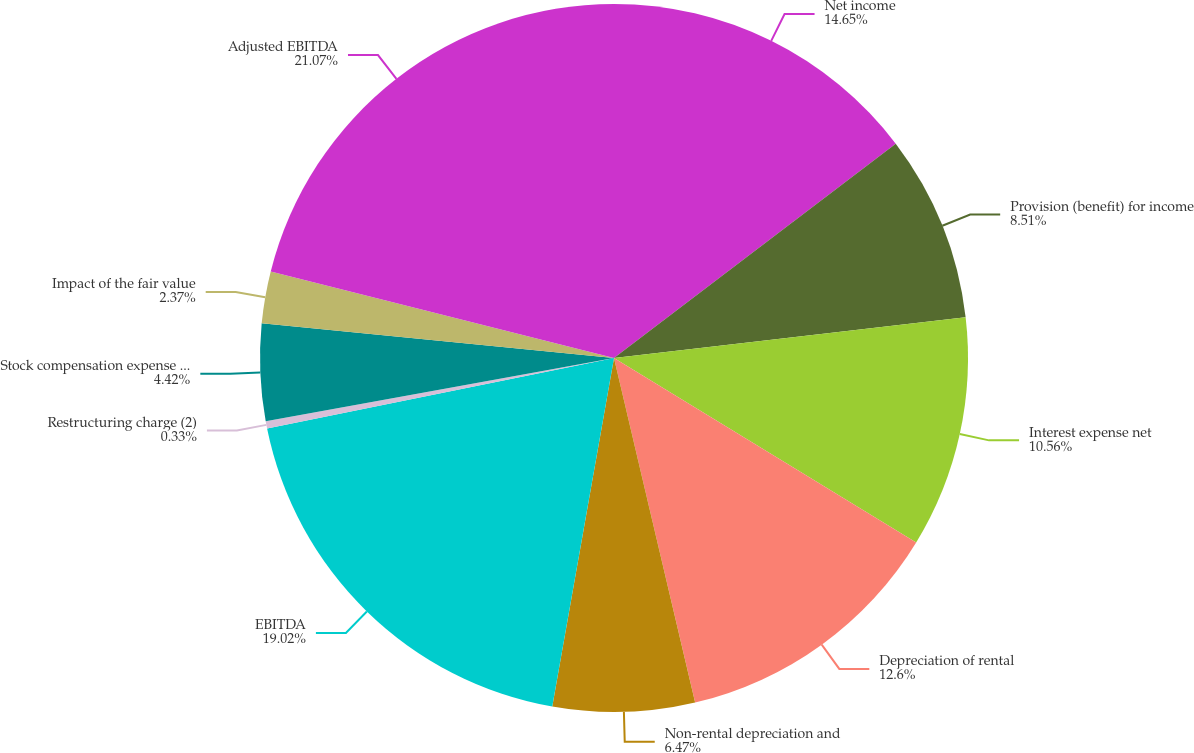Convert chart. <chart><loc_0><loc_0><loc_500><loc_500><pie_chart><fcel>Net income<fcel>Provision (benefit) for income<fcel>Interest expense net<fcel>Depreciation of rental<fcel>Non-rental depreciation and<fcel>EBITDA<fcel>Restructuring charge (2)<fcel>Stock compensation expense net<fcel>Impact of the fair value<fcel>Adjusted EBITDA<nl><fcel>14.65%<fcel>8.51%<fcel>10.56%<fcel>12.6%<fcel>6.47%<fcel>19.02%<fcel>0.33%<fcel>4.42%<fcel>2.37%<fcel>21.07%<nl></chart> 